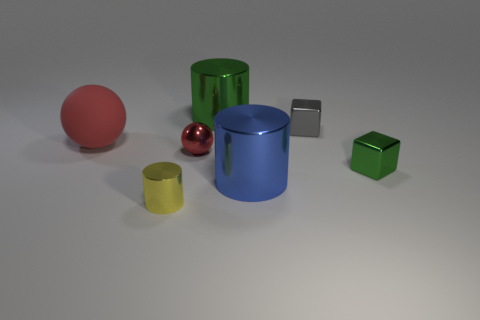There is a large red object that is the same shape as the small red metal object; what is its material?
Provide a succinct answer. Rubber. Are there any other things that have the same size as the gray metal block?
Ensure brevity in your answer.  Yes. The big metal object that is in front of the small ball has what shape?
Provide a short and direct response. Cylinder. How many other red things are the same shape as the red metallic object?
Offer a terse response. 1. Are there an equal number of small metallic balls that are in front of the green metal cube and large blue metallic cylinders that are in front of the big blue metal object?
Provide a succinct answer. Yes. Is there a small cyan cube made of the same material as the big blue cylinder?
Provide a short and direct response. No. Is the green cylinder made of the same material as the big blue object?
Provide a succinct answer. Yes. What number of red objects are metallic spheres or big matte spheres?
Provide a short and direct response. 2. Is the number of large balls on the right side of the large blue object greater than the number of large red objects?
Your response must be concise. No. Is there a large thing that has the same color as the big matte ball?
Ensure brevity in your answer.  No. 